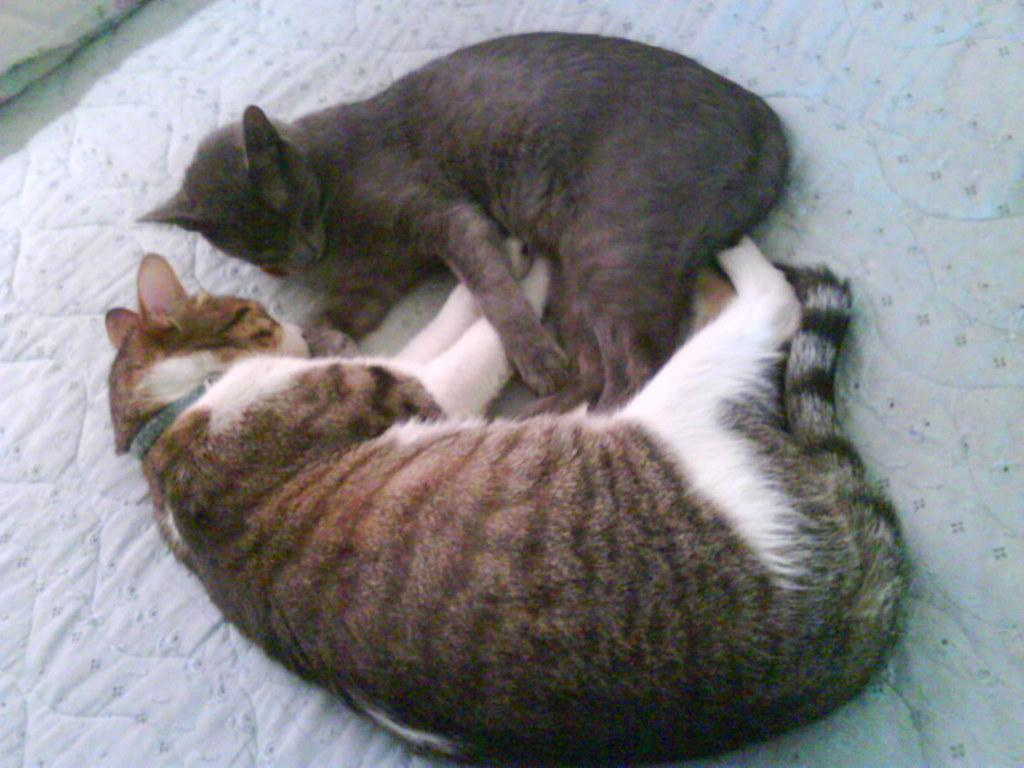How many cats are in the image? There are two cats in the image. What are the cats doing in the image? The cats are sleeping. Where are the cats located in the image? The cats are on a mattress. What type of payment is being made for the cats in the image? There is no payment being made in the image, as it features two cats sleeping on a mattress. What kind of cheese is visible in the image? There is no cheese present in the image. 